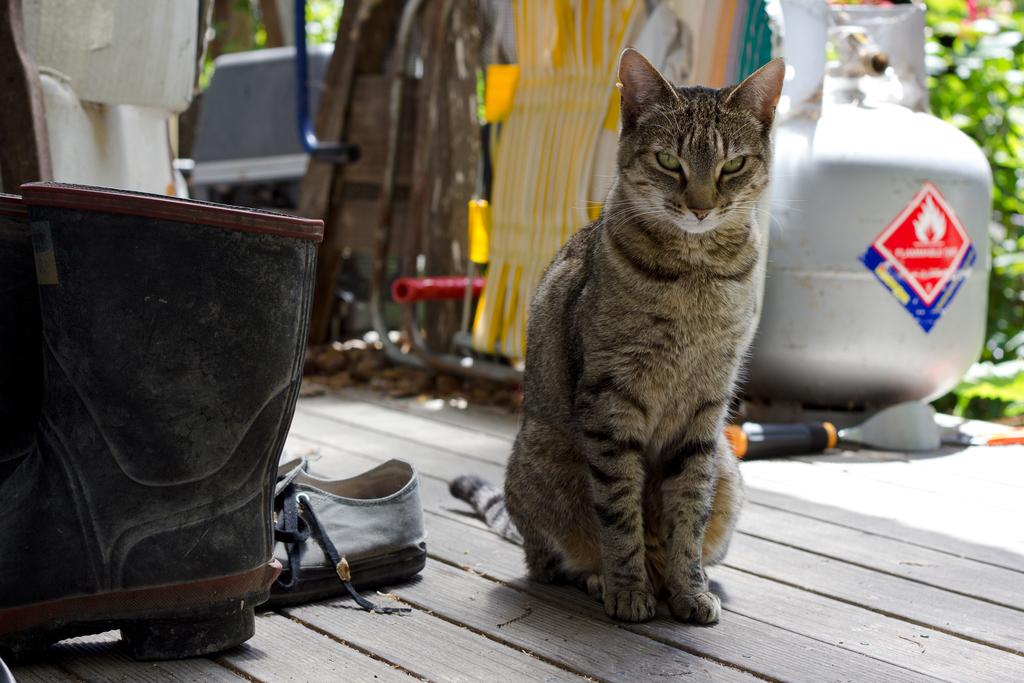What animal can be seen in the image? There is a cat in the image. Where is the cat sitting? The cat is sitting on a wooden platform. What type of items can be seen in the image besides the cat? Footwear is visible in the image. Can you describe the background of the image? The background of the image is blurry, and objects and green leaves are present. What type of punishment is the cat receiving in the image? There is no indication in the image that the cat is receiving any punishment. 